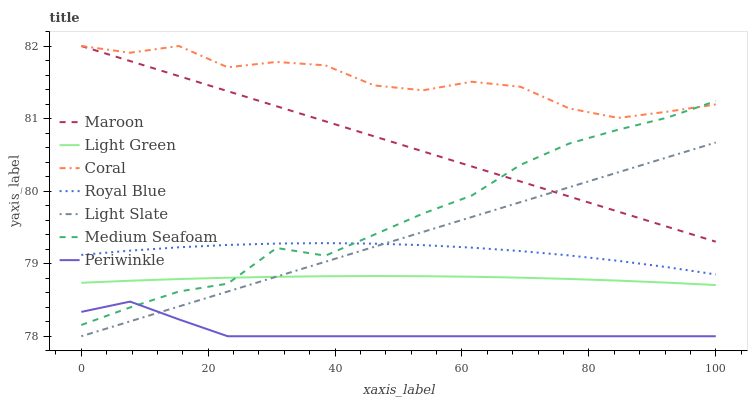Does Periwinkle have the minimum area under the curve?
Answer yes or no. Yes. Does Coral have the maximum area under the curve?
Answer yes or no. Yes. Does Maroon have the minimum area under the curve?
Answer yes or no. No. Does Maroon have the maximum area under the curve?
Answer yes or no. No. Is Maroon the smoothest?
Answer yes or no. Yes. Is Coral the roughest?
Answer yes or no. Yes. Is Coral the smoothest?
Answer yes or no. No. Is Maroon the roughest?
Answer yes or no. No. Does Light Slate have the lowest value?
Answer yes or no. Yes. Does Maroon have the lowest value?
Answer yes or no. No. Does Maroon have the highest value?
Answer yes or no. Yes. Does Royal Blue have the highest value?
Answer yes or no. No. Is Periwinkle less than Maroon?
Answer yes or no. Yes. Is Medium Seafoam greater than Light Slate?
Answer yes or no. Yes. Does Maroon intersect Light Slate?
Answer yes or no. Yes. Is Maroon less than Light Slate?
Answer yes or no. No. Is Maroon greater than Light Slate?
Answer yes or no. No. Does Periwinkle intersect Maroon?
Answer yes or no. No. 